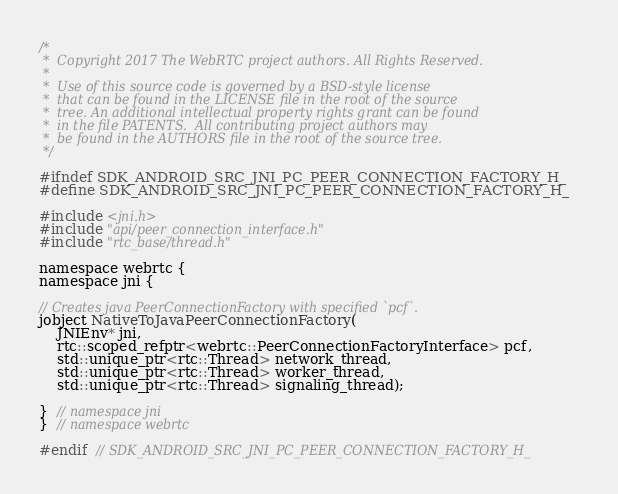<code> <loc_0><loc_0><loc_500><loc_500><_C_>/*
 *  Copyright 2017 The WebRTC project authors. All Rights Reserved.
 *
 *  Use of this source code is governed by a BSD-style license
 *  that can be found in the LICENSE file in the root of the source
 *  tree. An additional intellectual property rights grant can be found
 *  in the file PATENTS.  All contributing project authors may
 *  be found in the AUTHORS file in the root of the source tree.
 */

#ifndef SDK_ANDROID_SRC_JNI_PC_PEER_CONNECTION_FACTORY_H_
#define SDK_ANDROID_SRC_JNI_PC_PEER_CONNECTION_FACTORY_H_

#include <jni.h>
#include "api/peer_connection_interface.h"
#include "rtc_base/thread.h"

namespace webrtc {
namespace jni {

// Creates java PeerConnectionFactory with specified `pcf`.
jobject NativeToJavaPeerConnectionFactory(
    JNIEnv* jni,
    rtc::scoped_refptr<webrtc::PeerConnectionFactoryInterface> pcf,
    std::unique_ptr<rtc::Thread> network_thread,
    std::unique_ptr<rtc::Thread> worker_thread,
    std::unique_ptr<rtc::Thread> signaling_thread);

}  // namespace jni
}  // namespace webrtc

#endif  // SDK_ANDROID_SRC_JNI_PC_PEER_CONNECTION_FACTORY_H_
</code> 